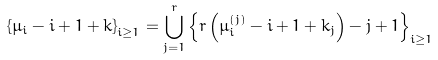Convert formula to latex. <formula><loc_0><loc_0><loc_500><loc_500>\left \{ \mu _ { i } - i + 1 + k \right \} _ { i \geq 1 } = \bigcup _ { j = 1 } ^ { r } \left \{ r \left ( \mu ^ { ( j ) } _ { i } - i + 1 + k _ { j } \right ) - j + 1 \right \} _ { i \geq 1 }</formula> 